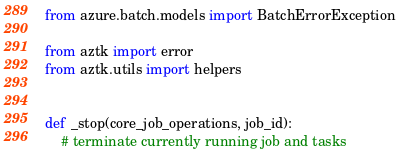<code> <loc_0><loc_0><loc_500><loc_500><_Python_>from azure.batch.models import BatchErrorException

from aztk import error
from aztk.utils import helpers


def _stop(core_job_operations, job_id):
    # terminate currently running job and tasks</code> 